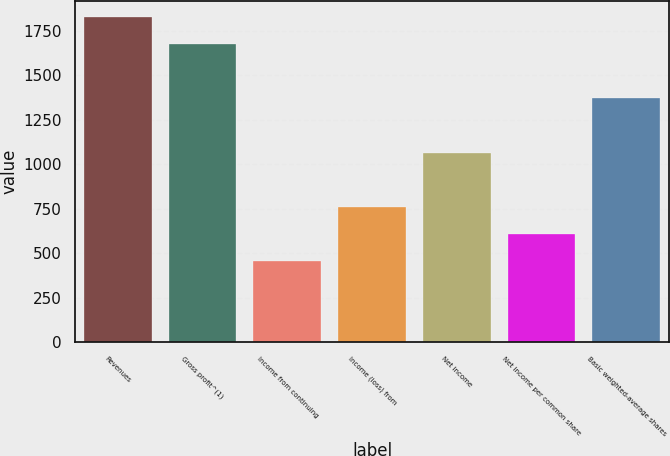Convert chart to OTSL. <chart><loc_0><loc_0><loc_500><loc_500><bar_chart><fcel>Revenues<fcel>Gross profit^(1)<fcel>Income from continuing<fcel>Income (loss) from<fcel>Net income<fcel>Net income per common share<fcel>Basic weighted-average shares<nl><fcel>1826.38<fcel>1674.19<fcel>456.67<fcel>761.05<fcel>1065.43<fcel>608.86<fcel>1369.81<nl></chart> 